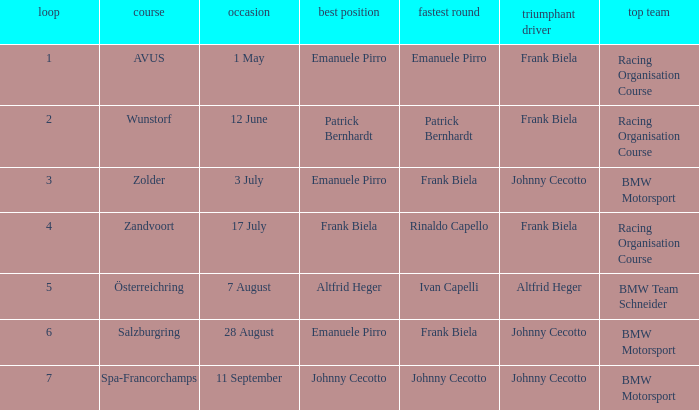Who had pole position in round 7? Johnny Cecotto. 